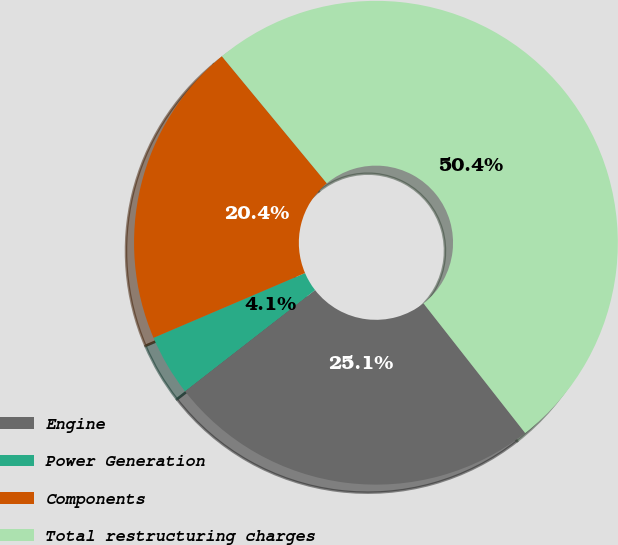Convert chart to OTSL. <chart><loc_0><loc_0><loc_500><loc_500><pie_chart><fcel>Engine<fcel>Power Generation<fcel>Components<fcel>Total restructuring charges<nl><fcel>25.07%<fcel>4.09%<fcel>20.44%<fcel>50.41%<nl></chart> 